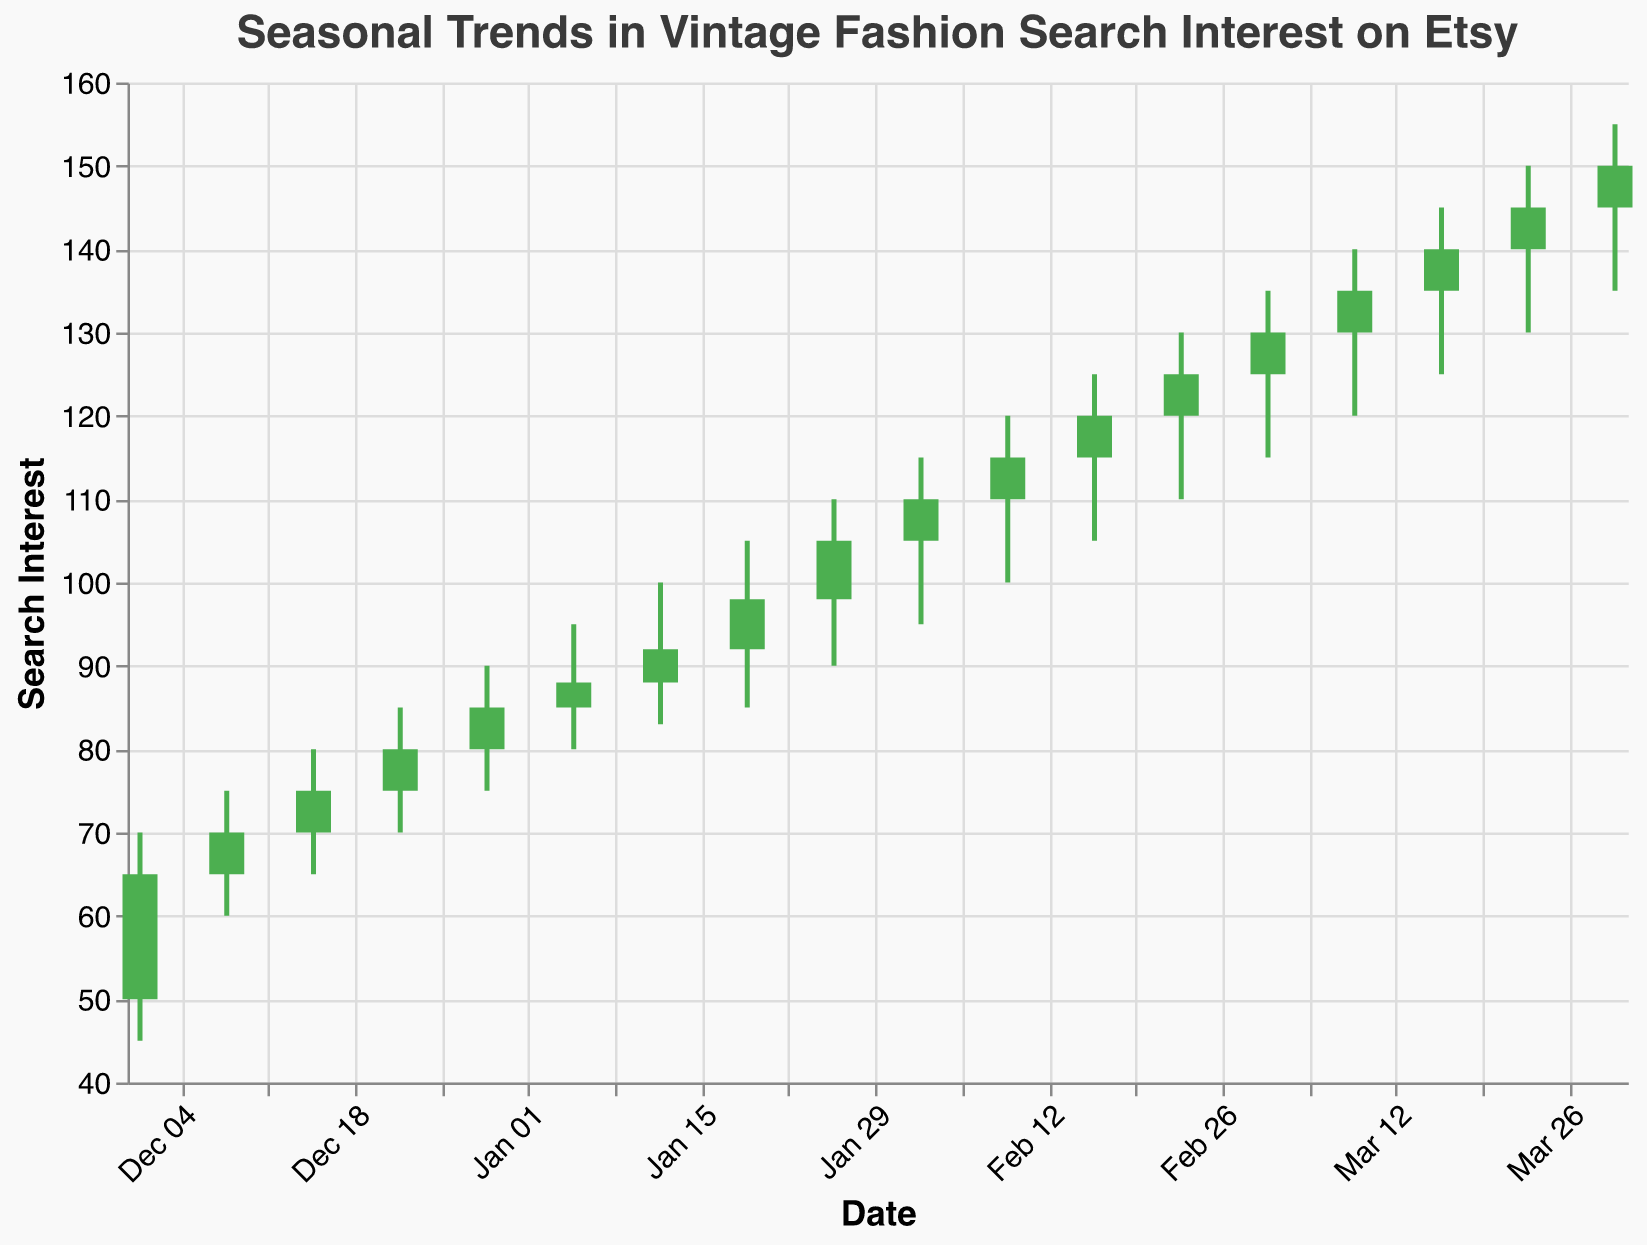What is the title of the figure? The title of the figure is displayed at the top and reads "Seasonal Trends in Vintage Fashion Search Interest on Etsy".
Answer: Seasonal Trends in Vintage Fashion Search Interest on Etsy What do the colors in the candlestick plot represent? The colors in the candlestick plot represent the change in search interest: green bars indicate an increase (Close > Open) and red bars indicate a decrease (Close < Open).
Answer: Change in search interest (green for increase, red for decrease) Which date shows the highest closing value in the plot? To find the highest closing value, look for the tallest ending bar across all the dates. The highest closing value is 150 on 2023-03-30.
Answer: 2023-03-30 Between which dates did the search interest increase the most based on the opening and closing values? To determine the largest increase, compare the difference between the closing and opening values for each week. The largest increase is from 2023-01-19 (Close = 98, Open = 92) to 2023-01-26 (Close = 105, Open = 98).
Answer: 2023-01-26 What is the range of the search interest covered by the y-axis? The y-axis values range from 40 to 160 based on the axis limits displayed.
Answer: 40 to 160 Identify the period with the most consistent increase in search interest. To find the most consistent increase, look for consecutive green bars that increase in value. From 2023-01-05 to 2023-03-30, search interest consistently increased.
Answer: 2023-01-05 to 2023-03-30 Compare the lowest search interest value in December 2022 with the highest search interest value in December 2022. The lowest value in December 2022 is 45 on 2022-12-01, and the highest value is 90 on 2022-12-29.
Answer: Lowest: 45, Highest: 90 Which week had the largest difference between the high and low search interest values? To find this, subtract the low value from the high value for each date. The largest difference is between 2023-01-19 where the high is 105 and the low is 85, resulting in a difference of 20.
Answer: 2023-01-19 What trend can be observed from December 2022 to March 2023? Observing the overall movement of the candlesticks, the trend shows a steady increase in search interest from December 2022 to March 2023.
Answer: Steady increase What is the median closing value for the entire period? To find the median, list all closing values and find the middle one. The values are (65, 70, 75, 80, 85, 88, 92, 98, 105, 110, 115, 120, 125, 130, 135, 140, 145, 150). The middle values are 105 and 110; thus, the median is (105 + 110) / 2 = 107.5.
Answer: 107.5 